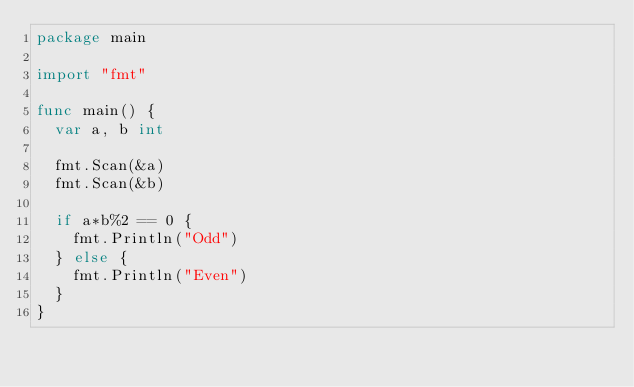<code> <loc_0><loc_0><loc_500><loc_500><_Go_>package main

import "fmt"

func main() {
	var a, b int

	fmt.Scan(&a)
	fmt.Scan(&b)

	if a*b%2 == 0 {
		fmt.Println("Odd")
	} else {
		fmt.Println("Even")
	}
}
</code> 